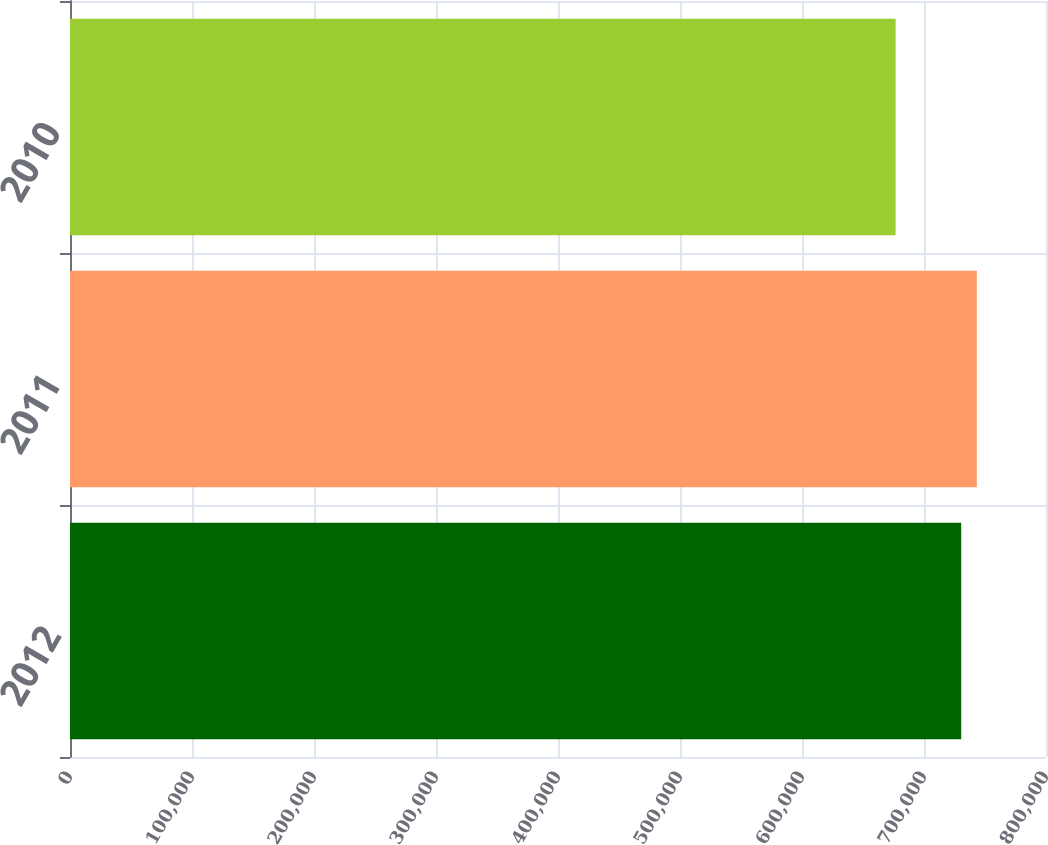Convert chart to OTSL. <chart><loc_0><loc_0><loc_500><loc_500><bar_chart><fcel>2012<fcel>2011<fcel>2010<nl><fcel>730489<fcel>743308<fcel>676738<nl></chart> 